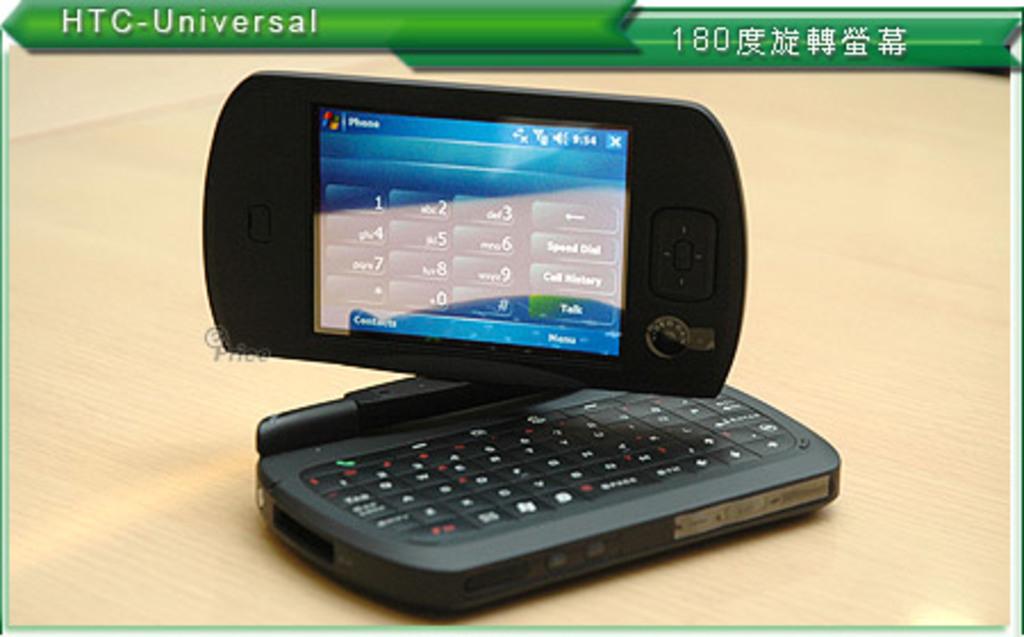What number is in the upper right green banner?
Make the answer very short. 180. 